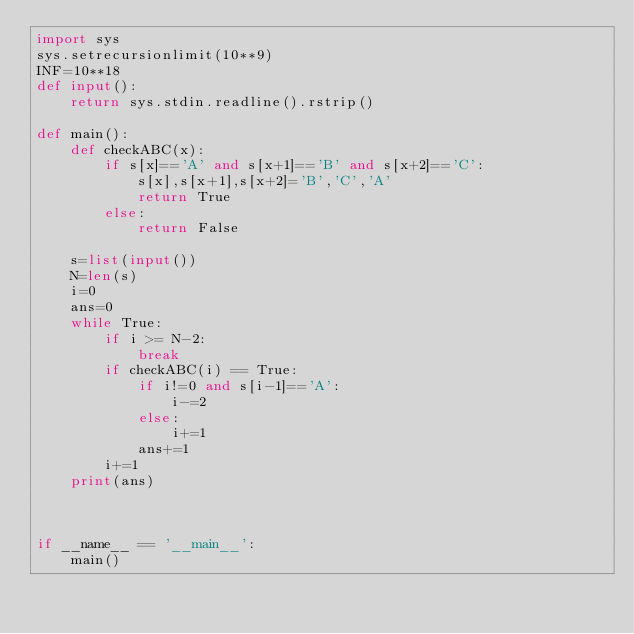Convert code to text. <code><loc_0><loc_0><loc_500><loc_500><_Python_>import sys
sys.setrecursionlimit(10**9)
INF=10**18
def input():
    return sys.stdin.readline().rstrip()

def main():
    def checkABC(x):
        if s[x]=='A' and s[x+1]=='B' and s[x+2]=='C':
            s[x],s[x+1],s[x+2]='B','C','A'
            return True
        else:
            return False
    
    s=list(input())
    N=len(s)
    i=0
    ans=0
    while True:
        if i >= N-2:
            break
        if checkABC(i) == True:
            if i!=0 and s[i-1]=='A':
                i-=2
            else:
                i+=1
            ans+=1
        i+=1
    print(ans)
        
        

if __name__ == '__main__':
    main()
</code> 